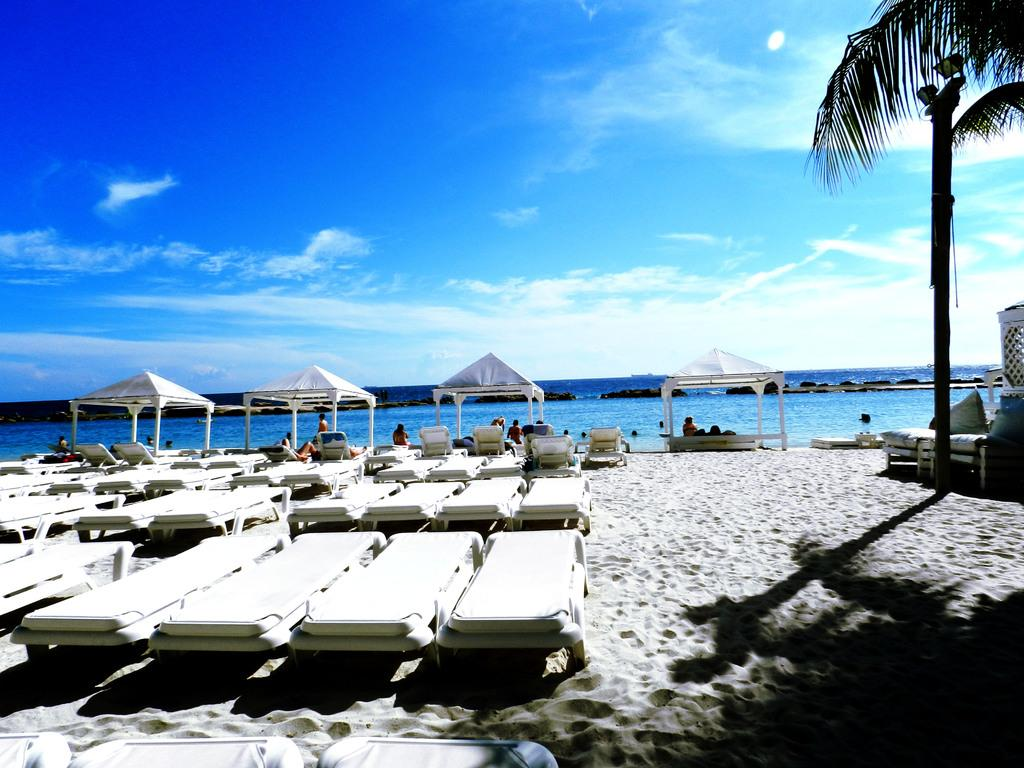What is the main subject of the image? The main subject of the image is a water flow. What are the people in the image doing? The people in the image are sitting under tents. What type of natural vegetation is visible in the image? There are trees visible in the image. What type of representative can be seen in the image? There is no representative present in the image. What type of ice can be seen melting in the image? There is no ice present in the image. 